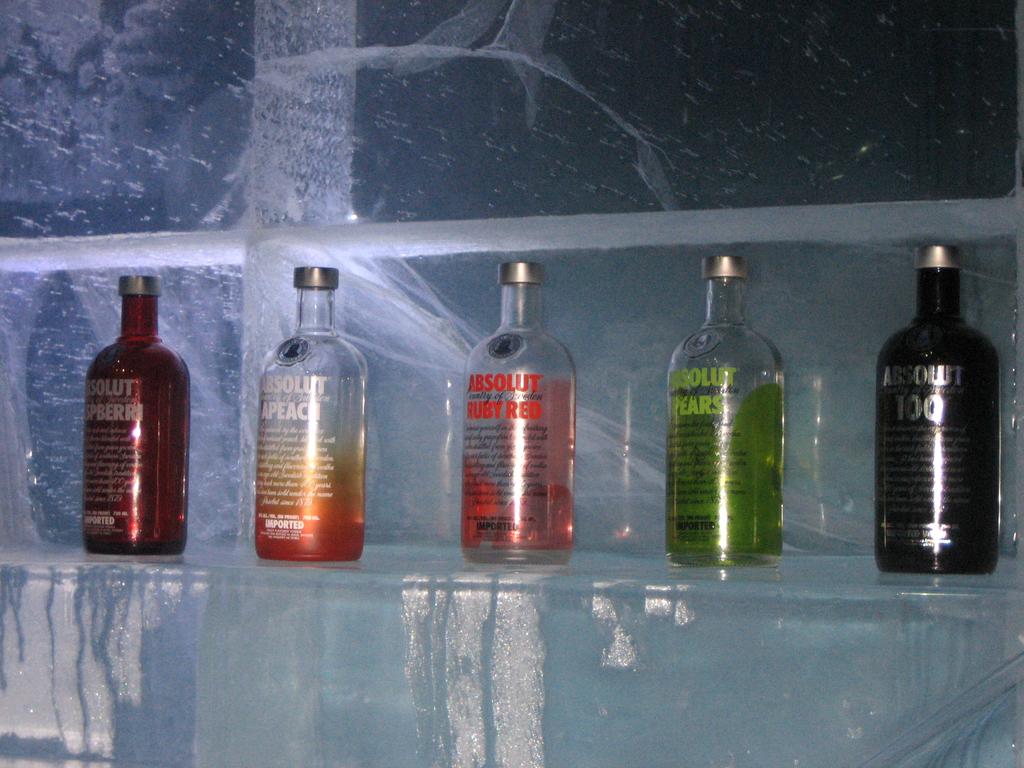What flavor is the green drink?
Provide a short and direct response. Pears. 